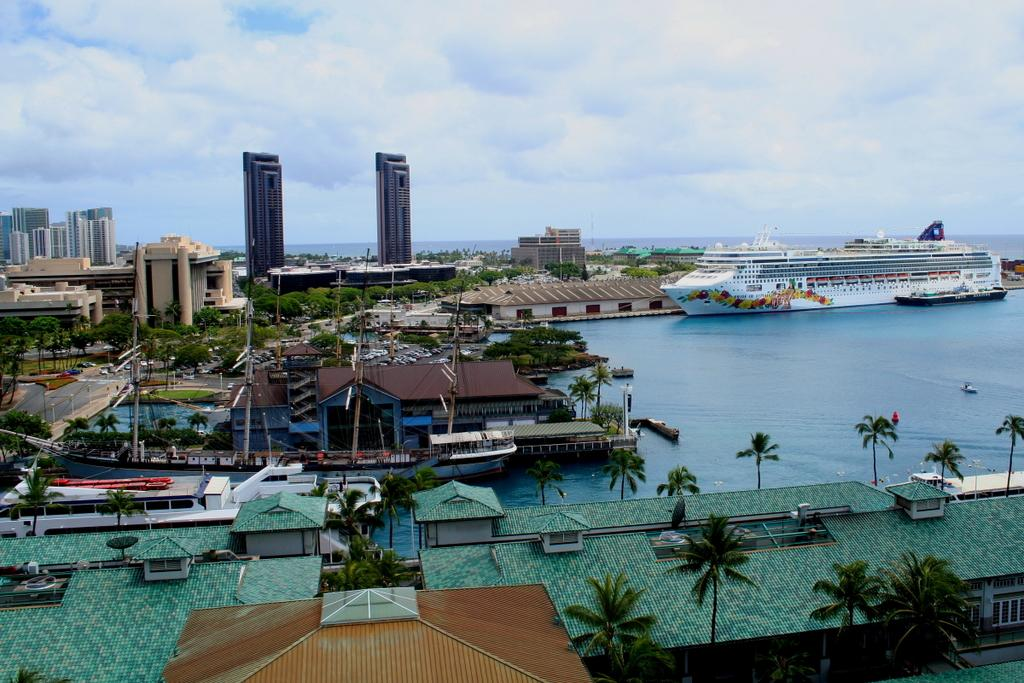What is the main subject of the image? The main subject of the image is a ship. What else can be seen on the water in the image? There are boats on the water in the image. What type of structures are visible in the image? There are houses and buildings in the image. What type of vegetation is present in the image? There are trees in the image. What else can be seen in the image besides the ship, boats, houses, buildings, and trees? There are objects in the image. What is visible in the background of the image? The sky is visible in the background of the image, and clouds are present in the sky. What type of glue is being used to hold the face of the building together in the image? There is no glue or face of a building present in the image. 